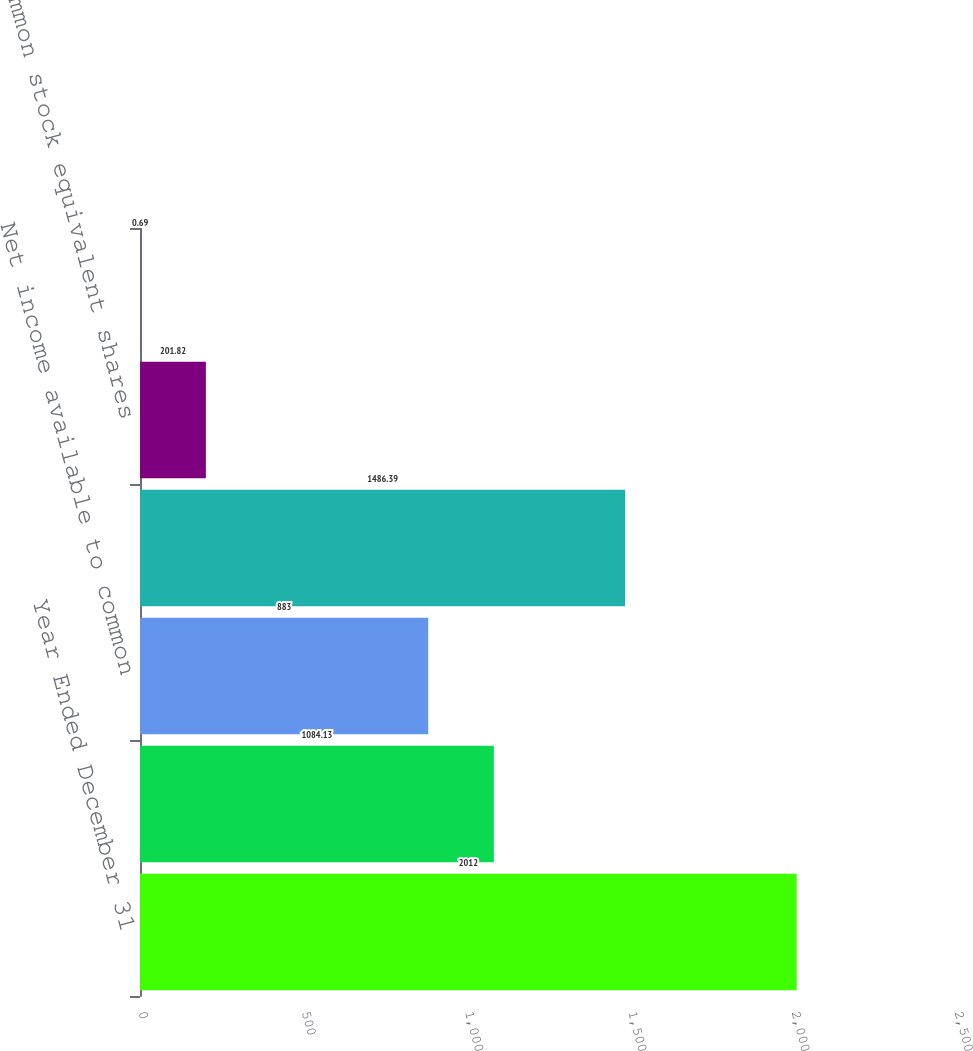Convert chart. <chart><loc_0><loc_0><loc_500><loc_500><bar_chart><fcel>Year Ended December 31<fcel>Net income<fcel>Net income available to common<fcel>Weighted-average common shares<fcel>Common stock equivalent shares<fcel>Basic EPS<nl><fcel>2012<fcel>1084.13<fcel>883<fcel>1486.39<fcel>201.82<fcel>0.69<nl></chart> 